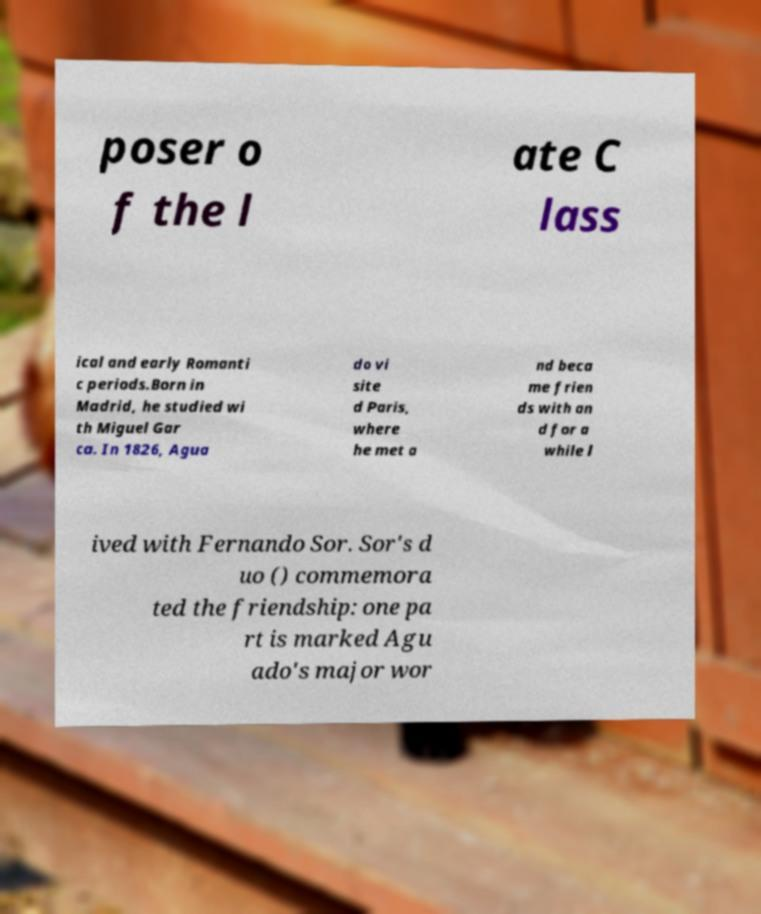Can you read and provide the text displayed in the image?This photo seems to have some interesting text. Can you extract and type it out for me? poser o f the l ate C lass ical and early Romanti c periods.Born in Madrid, he studied wi th Miguel Gar ca. In 1826, Agua do vi site d Paris, where he met a nd beca me frien ds with an d for a while l ived with Fernando Sor. Sor's d uo () commemora ted the friendship: one pa rt is marked Agu ado's major wor 